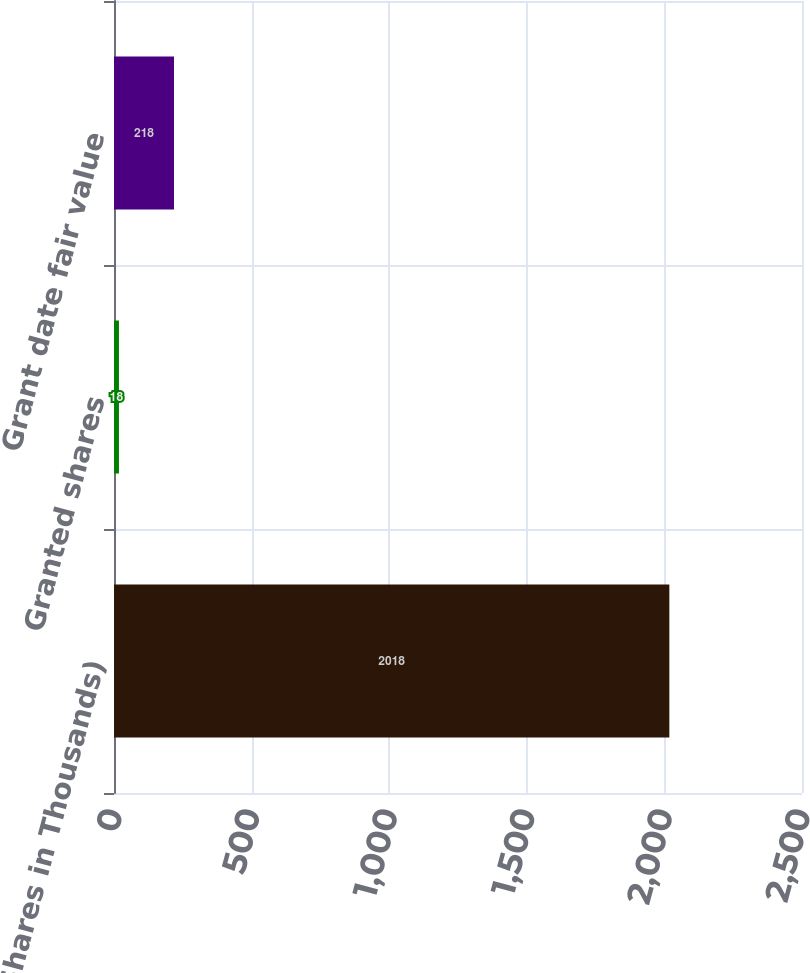Convert chart to OTSL. <chart><loc_0><loc_0><loc_500><loc_500><bar_chart><fcel>(Shares in Thousands)<fcel>Granted shares<fcel>Grant date fair value<nl><fcel>2018<fcel>18<fcel>218<nl></chart> 